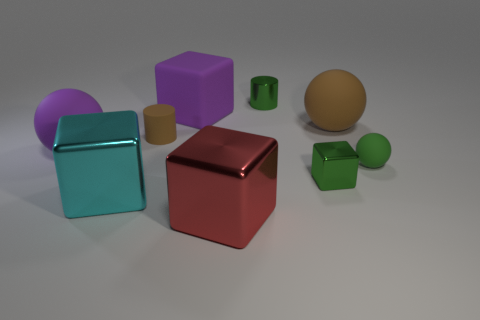Subtract all brown cubes. Subtract all green cylinders. How many cubes are left? 4 Subtract all blocks. How many objects are left? 5 Add 6 large purple rubber blocks. How many large purple rubber blocks are left? 7 Add 8 small red matte objects. How many small red matte objects exist? 8 Subtract 1 purple blocks. How many objects are left? 8 Subtract all brown rubber spheres. Subtract all cyan metal things. How many objects are left? 7 